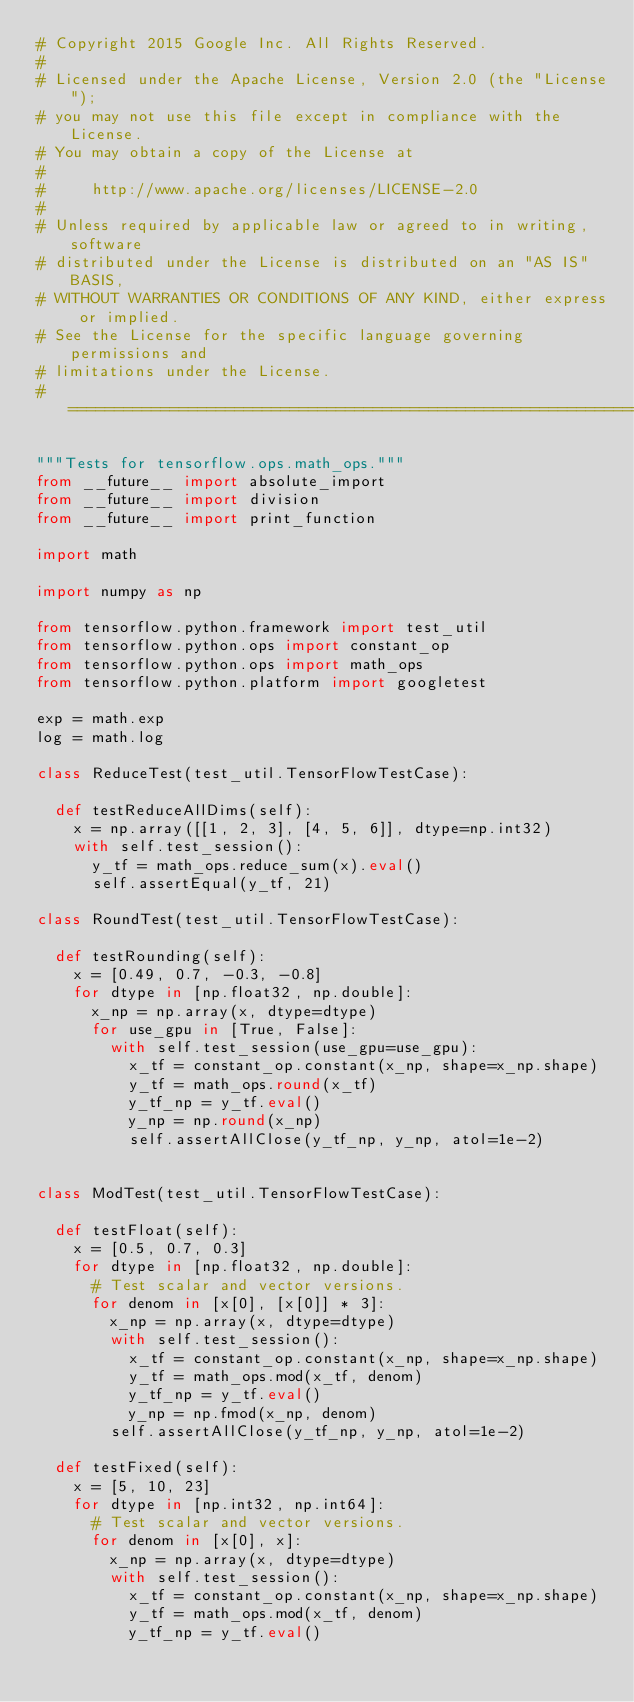Convert code to text. <code><loc_0><loc_0><loc_500><loc_500><_Python_># Copyright 2015 Google Inc. All Rights Reserved.
#
# Licensed under the Apache License, Version 2.0 (the "License");
# you may not use this file except in compliance with the License.
# You may obtain a copy of the License at
#
#     http://www.apache.org/licenses/LICENSE-2.0
#
# Unless required by applicable law or agreed to in writing, software
# distributed under the License is distributed on an "AS IS" BASIS,
# WITHOUT WARRANTIES OR CONDITIONS OF ANY KIND, either express or implied.
# See the License for the specific language governing permissions and
# limitations under the License.
# ==============================================================================

"""Tests for tensorflow.ops.math_ops."""
from __future__ import absolute_import
from __future__ import division
from __future__ import print_function

import math

import numpy as np

from tensorflow.python.framework import test_util
from tensorflow.python.ops import constant_op
from tensorflow.python.ops import math_ops
from tensorflow.python.platform import googletest

exp = math.exp
log = math.log

class ReduceTest(test_util.TensorFlowTestCase):

  def testReduceAllDims(self):
    x = np.array([[1, 2, 3], [4, 5, 6]], dtype=np.int32)
    with self.test_session():
      y_tf = math_ops.reduce_sum(x).eval()
      self.assertEqual(y_tf, 21)

class RoundTest(test_util.TensorFlowTestCase):

  def testRounding(self):
    x = [0.49, 0.7, -0.3, -0.8]
    for dtype in [np.float32, np.double]:
      x_np = np.array(x, dtype=dtype)
      for use_gpu in [True, False]:
        with self.test_session(use_gpu=use_gpu):
          x_tf = constant_op.constant(x_np, shape=x_np.shape)
          y_tf = math_ops.round(x_tf)
          y_tf_np = y_tf.eval()
          y_np = np.round(x_np)
          self.assertAllClose(y_tf_np, y_np, atol=1e-2)


class ModTest(test_util.TensorFlowTestCase):

  def testFloat(self):
    x = [0.5, 0.7, 0.3]
    for dtype in [np.float32, np.double]:
      # Test scalar and vector versions.
      for denom in [x[0], [x[0]] * 3]:
        x_np = np.array(x, dtype=dtype)
        with self.test_session():
          x_tf = constant_op.constant(x_np, shape=x_np.shape)
          y_tf = math_ops.mod(x_tf, denom)
          y_tf_np = y_tf.eval()
          y_np = np.fmod(x_np, denom)
        self.assertAllClose(y_tf_np, y_np, atol=1e-2)

  def testFixed(self):
    x = [5, 10, 23]
    for dtype in [np.int32, np.int64]:
      # Test scalar and vector versions.
      for denom in [x[0], x]:
        x_np = np.array(x, dtype=dtype)
        with self.test_session():
          x_tf = constant_op.constant(x_np, shape=x_np.shape)
          y_tf = math_ops.mod(x_tf, denom)
          y_tf_np = y_tf.eval()</code> 